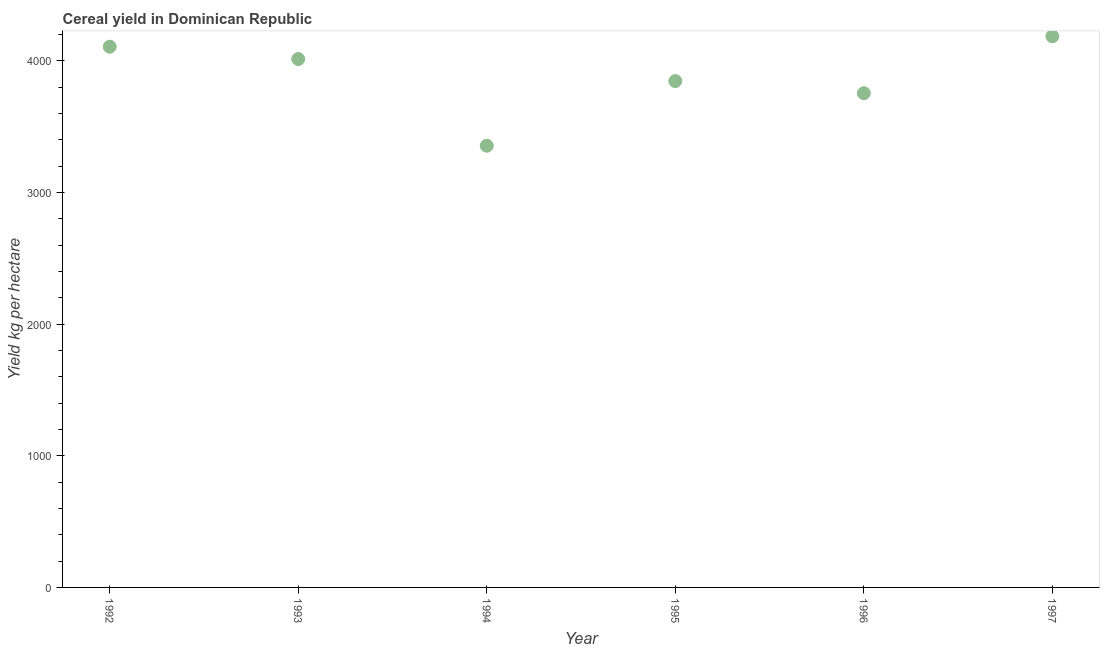What is the cereal yield in 1992?
Give a very brief answer. 4108.39. Across all years, what is the maximum cereal yield?
Your answer should be compact. 4187.58. Across all years, what is the minimum cereal yield?
Offer a terse response. 3356.01. In which year was the cereal yield maximum?
Offer a terse response. 1997. In which year was the cereal yield minimum?
Provide a short and direct response. 1994. What is the sum of the cereal yield?
Give a very brief answer. 2.33e+04. What is the difference between the cereal yield in 1995 and 1997?
Provide a short and direct response. -340.25. What is the average cereal yield per year?
Make the answer very short. 3878.22. What is the median cereal yield?
Offer a terse response. 3931.07. Do a majority of the years between 1996 and 1993 (inclusive) have cereal yield greater than 3600 kg per hectare?
Give a very brief answer. Yes. What is the ratio of the cereal yield in 1993 to that in 1997?
Offer a terse response. 0.96. Is the difference between the cereal yield in 1992 and 1996 greater than the difference between any two years?
Ensure brevity in your answer.  No. What is the difference between the highest and the second highest cereal yield?
Your answer should be very brief. 79.19. Is the sum of the cereal yield in 1992 and 1997 greater than the maximum cereal yield across all years?
Provide a succinct answer. Yes. What is the difference between the highest and the lowest cereal yield?
Give a very brief answer. 831.57. How many dotlines are there?
Your answer should be very brief. 1. What is the title of the graph?
Offer a terse response. Cereal yield in Dominican Republic. What is the label or title of the Y-axis?
Provide a succinct answer. Yield kg per hectare. What is the Yield kg per hectare in 1992?
Your response must be concise. 4108.39. What is the Yield kg per hectare in 1993?
Keep it short and to the point. 4014.82. What is the Yield kg per hectare in 1994?
Keep it short and to the point. 3356.01. What is the Yield kg per hectare in 1995?
Your answer should be compact. 3847.33. What is the Yield kg per hectare in 1996?
Ensure brevity in your answer.  3755.2. What is the Yield kg per hectare in 1997?
Offer a terse response. 4187.58. What is the difference between the Yield kg per hectare in 1992 and 1993?
Keep it short and to the point. 93.57. What is the difference between the Yield kg per hectare in 1992 and 1994?
Ensure brevity in your answer.  752.38. What is the difference between the Yield kg per hectare in 1992 and 1995?
Your response must be concise. 261.06. What is the difference between the Yield kg per hectare in 1992 and 1996?
Give a very brief answer. 353.19. What is the difference between the Yield kg per hectare in 1992 and 1997?
Provide a short and direct response. -79.19. What is the difference between the Yield kg per hectare in 1993 and 1994?
Keep it short and to the point. 658.81. What is the difference between the Yield kg per hectare in 1993 and 1995?
Provide a short and direct response. 167.49. What is the difference between the Yield kg per hectare in 1993 and 1996?
Provide a succinct answer. 259.62. What is the difference between the Yield kg per hectare in 1993 and 1997?
Provide a succinct answer. -172.77. What is the difference between the Yield kg per hectare in 1994 and 1995?
Your answer should be very brief. -491.32. What is the difference between the Yield kg per hectare in 1994 and 1996?
Offer a terse response. -399.19. What is the difference between the Yield kg per hectare in 1994 and 1997?
Provide a succinct answer. -831.58. What is the difference between the Yield kg per hectare in 1995 and 1996?
Offer a very short reply. 92.13. What is the difference between the Yield kg per hectare in 1995 and 1997?
Your answer should be compact. -340.25. What is the difference between the Yield kg per hectare in 1996 and 1997?
Give a very brief answer. -432.38. What is the ratio of the Yield kg per hectare in 1992 to that in 1993?
Ensure brevity in your answer.  1.02. What is the ratio of the Yield kg per hectare in 1992 to that in 1994?
Provide a succinct answer. 1.22. What is the ratio of the Yield kg per hectare in 1992 to that in 1995?
Offer a very short reply. 1.07. What is the ratio of the Yield kg per hectare in 1992 to that in 1996?
Ensure brevity in your answer.  1.09. What is the ratio of the Yield kg per hectare in 1993 to that in 1994?
Provide a short and direct response. 1.2. What is the ratio of the Yield kg per hectare in 1993 to that in 1995?
Your answer should be very brief. 1.04. What is the ratio of the Yield kg per hectare in 1993 to that in 1996?
Your answer should be very brief. 1.07. What is the ratio of the Yield kg per hectare in 1993 to that in 1997?
Your answer should be very brief. 0.96. What is the ratio of the Yield kg per hectare in 1994 to that in 1995?
Ensure brevity in your answer.  0.87. What is the ratio of the Yield kg per hectare in 1994 to that in 1996?
Offer a terse response. 0.89. What is the ratio of the Yield kg per hectare in 1994 to that in 1997?
Give a very brief answer. 0.8. What is the ratio of the Yield kg per hectare in 1995 to that in 1996?
Your answer should be very brief. 1.02. What is the ratio of the Yield kg per hectare in 1995 to that in 1997?
Offer a terse response. 0.92. What is the ratio of the Yield kg per hectare in 1996 to that in 1997?
Make the answer very short. 0.9. 